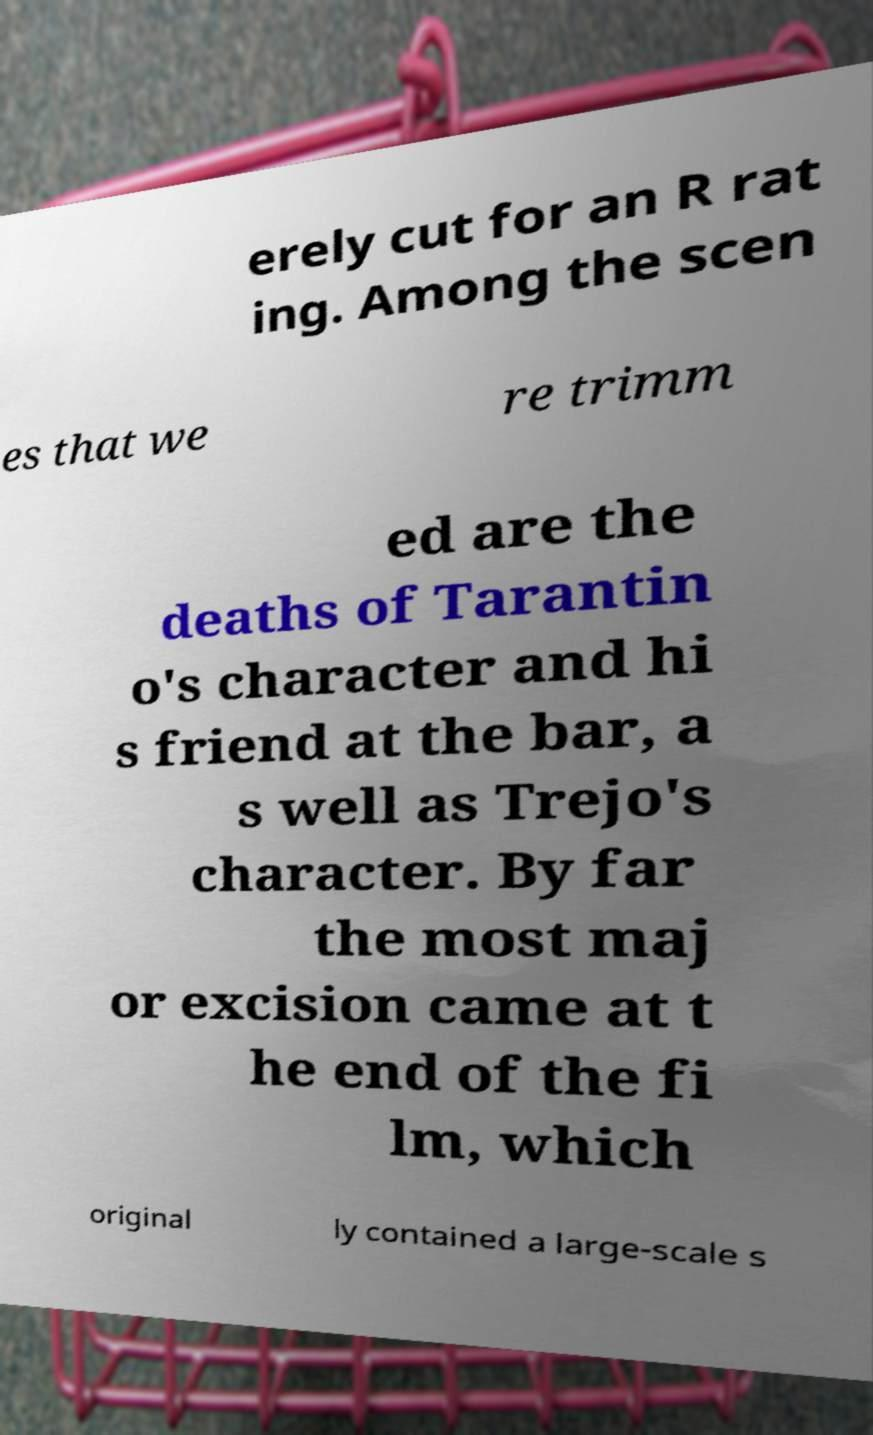I need the written content from this picture converted into text. Can you do that? erely cut for an R rat ing. Among the scen es that we re trimm ed are the deaths of Tarantin o's character and hi s friend at the bar, a s well as Trejo's character. By far the most maj or excision came at t he end of the fi lm, which original ly contained a large-scale s 